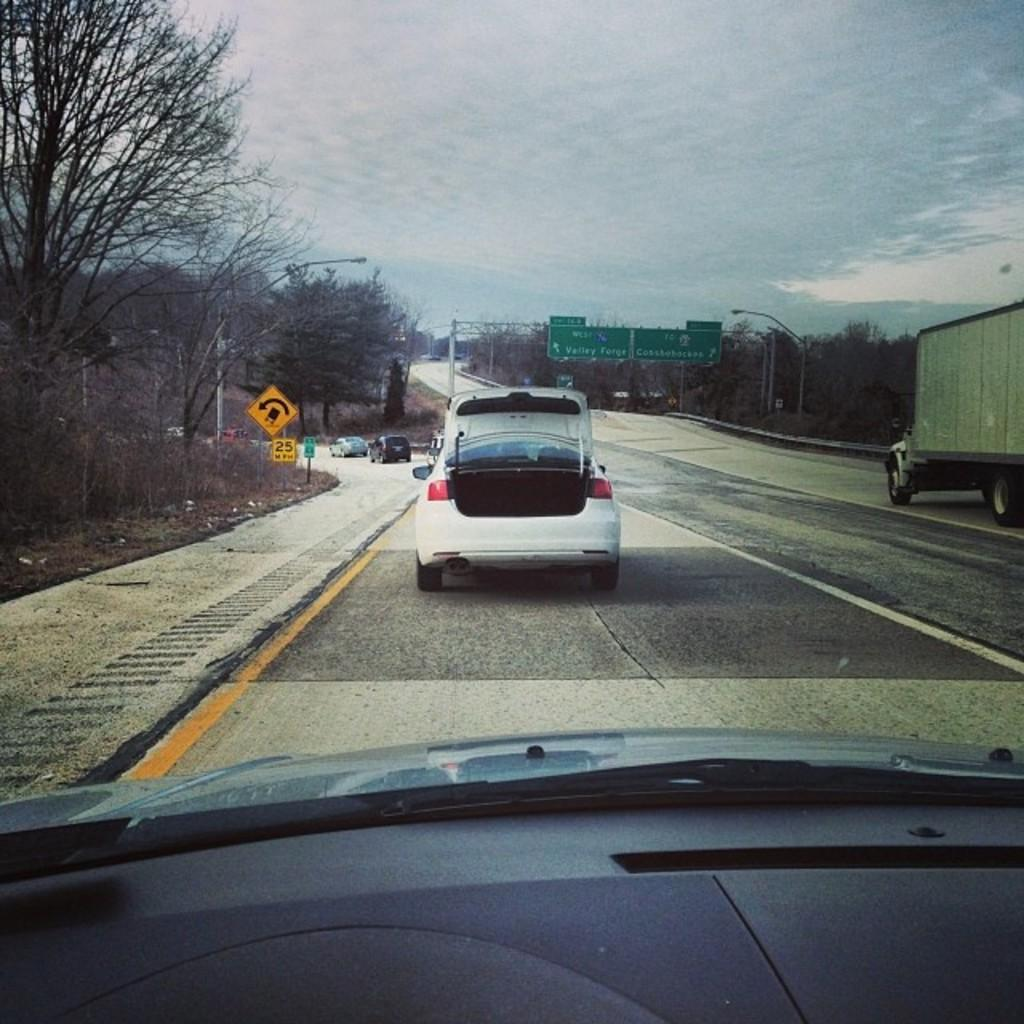What type of vehicles can be seen on the road in the image? There are cars on the road in the image. What is present on the road that might be used for racing or other events? There is a track on the road in the image. What structures are present on both sides of the road in the image? Sign boards and poles are present on both sides of the road in the image. What type of vegetation is present on both sides of the road in the image? Trees are present on both sides of the road in the image. What is visible at the top of the image? The sky is visible at the top of the image. What can be seen in the sky in the image? Clouds are present in the sky. Where is the expert sitting on a swing in the image? There is no expert or swing present in the image. Is there any snow visible in the image? No, there is no snow present in the image. 